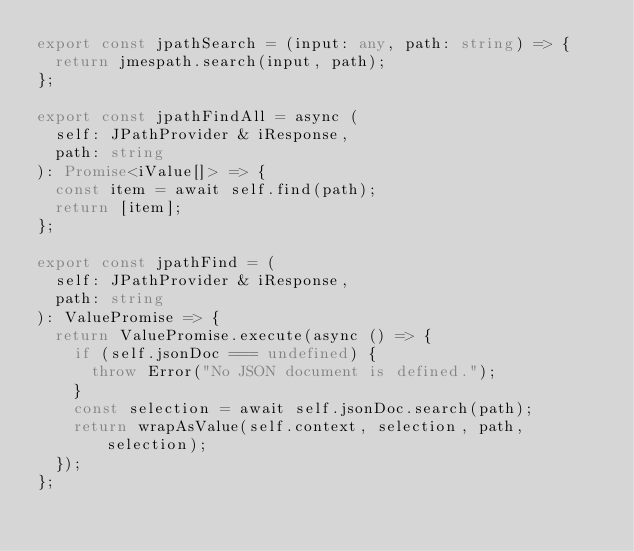<code> <loc_0><loc_0><loc_500><loc_500><_TypeScript_>export const jpathSearch = (input: any, path: string) => {
  return jmespath.search(input, path);
};

export const jpathFindAll = async (
  self: JPathProvider & iResponse,
  path: string
): Promise<iValue[]> => {
  const item = await self.find(path);
  return [item];
};

export const jpathFind = (
  self: JPathProvider & iResponse,
  path: string
): ValuePromise => {
  return ValuePromise.execute(async () => {
    if (self.jsonDoc === undefined) {
      throw Error("No JSON document is defined.");
    }
    const selection = await self.jsonDoc.search(path);
    return wrapAsValue(self.context, selection, path, selection);
  });
};
</code> 